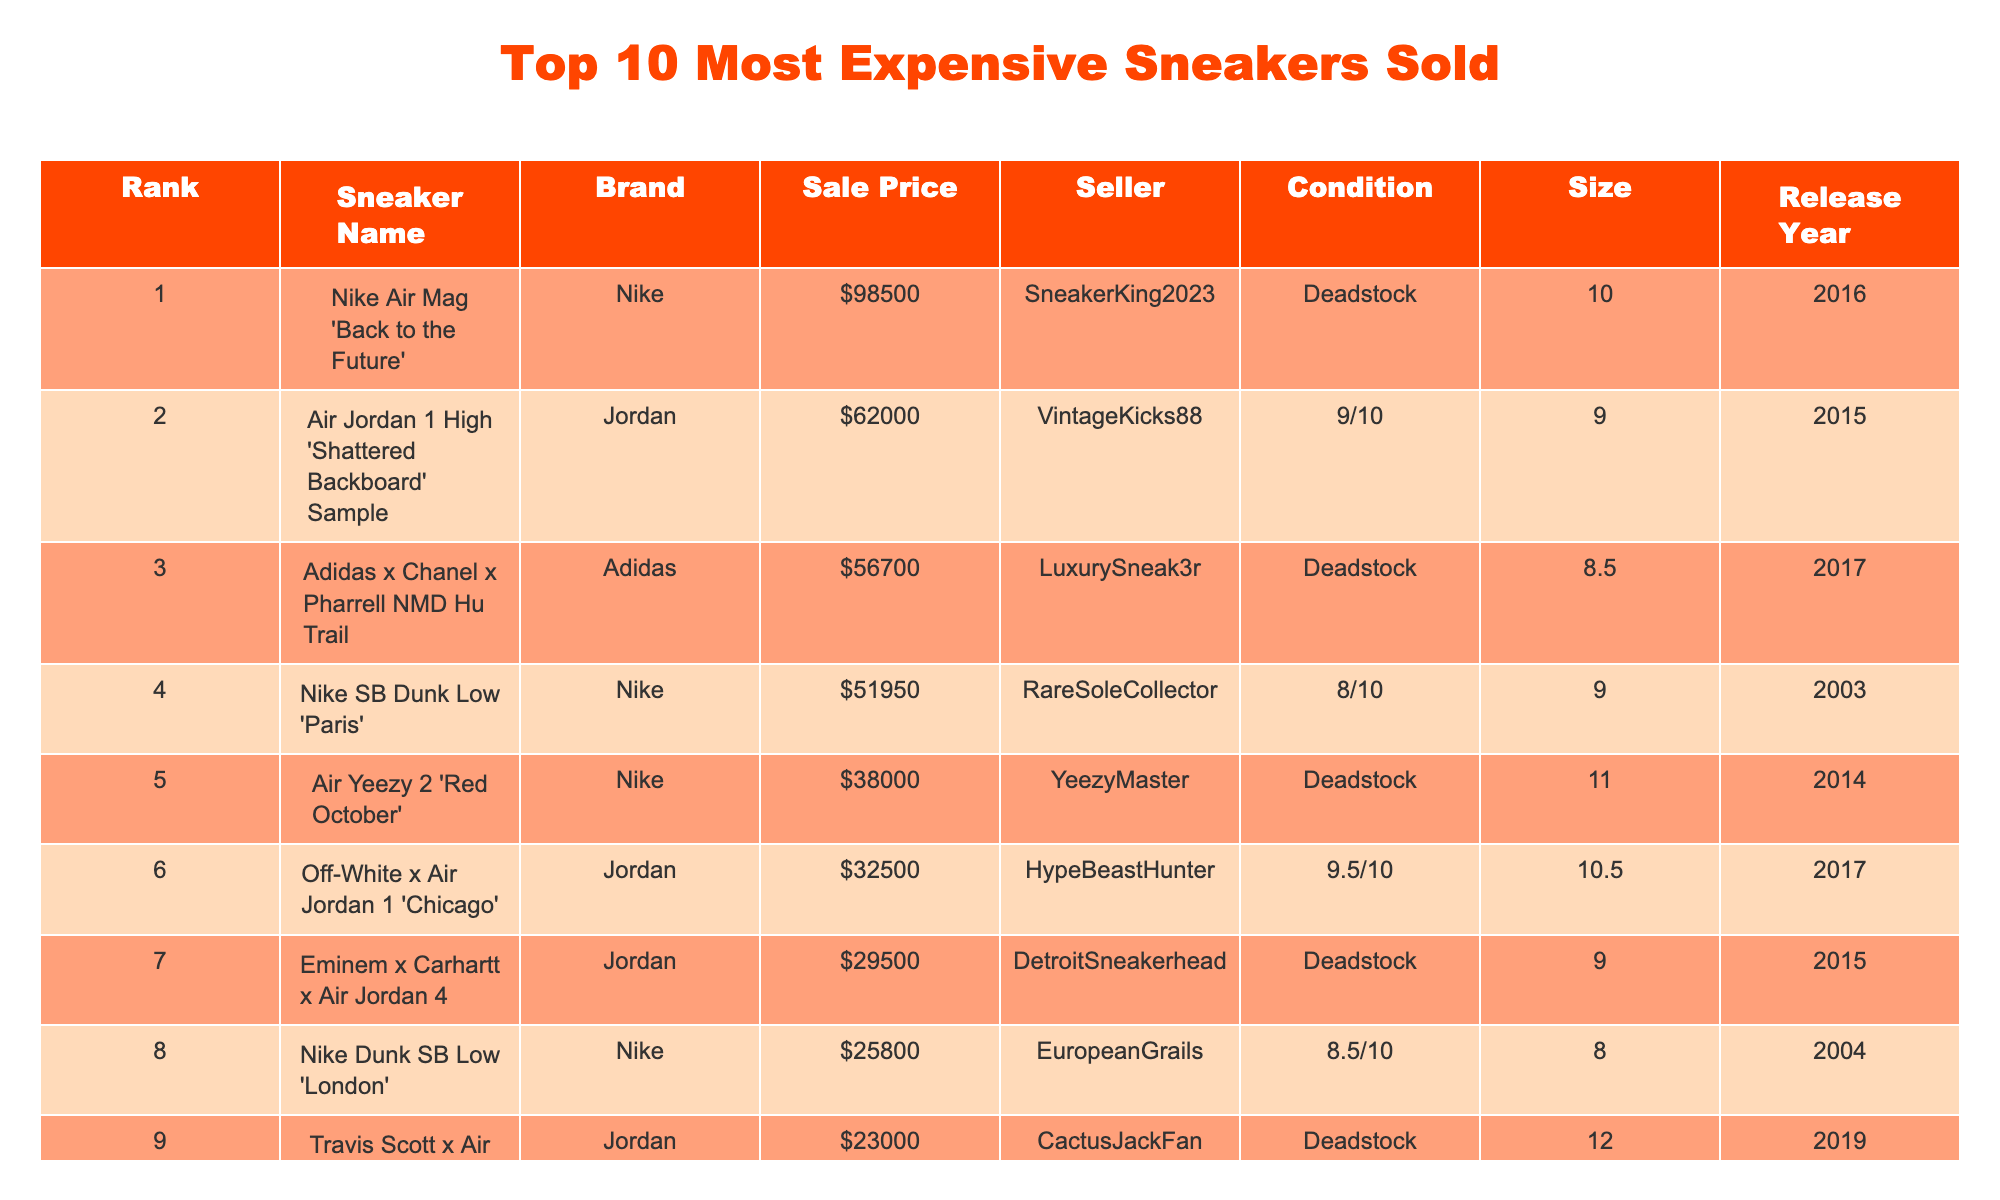What is the sale price of the Nike Air Mag 'Back to the Future'? The table lists the Nike Air Mag 'Back to the Future' with a sale price of $98,500.
Answer: $98,500 Which brand has the most sneakers in the top 10 list? The table shows that Nike has 5 entries (Nike Air Mag, Nike SB Dunk, Air Yeezy, Off-White x Air Jordan, and Nike Dunk) compared to Jordan with 4 entries.
Answer: Nike What is the condition of the sneaker sold for the highest price? The highest-priced sneaker, the Nike Air Mag 'Back to the Future', is listed as deadstock.
Answer: Deadstock How much did the Air Jordan 1 High 'Shattered Backboard' Sample sell for? The table states that the Air Jordan 1 High 'Shattered Backboard' Sample sold for $62,000.
Answer: $62,000 What is the average sale price of all sneakers listed in the table? Adding up all sale prices ($98,500 + $62,000 + $56,700 + $51,950 + $38,000 + $32,500 + $29,500 + $25,800 + $23,000 + $21,500 = $414,450) and dividing by 10 gives an average sale price of $41,445.
Answer: $41,445 Is there a sneaker sold for less than $25,000? The table does not display any sneaker sold for less than $25,000, as the lowest price is $21,500.
Answer: No Which sneaker had the highest sale price among those released in 2017? The Adidas x Chanel x Pharrell NMD Hu Trail, released in 2017, sold for $56,700 and is the highest-priced sneaker from that year.
Answer: Adidas x Chanel x Pharrell NMD Hu Trail How many sneakers listed are deadstock? The table shows that there are six deadstock sneakers (Nike Air Mag, Adidas x Chanel x Pharrell NMD Hu Trail, Air Yeezy 2, Eminem x Carhartt x Air Jordan 4, and Travis Scott x Air Jordan 1).
Answer: 6 What is the difference in sale price between the most expensive and the least expensive sneaker? The most expensive sneaker is the Nike Air Mag at $98,500, and the least expensive is the Kanye West x Louis Vuitton 'Don' at $21,500; the difference is $98,500 - $21,500 = $77,000.
Answer: $77,000 Which sneaker is the oldest in the top 10 list? The Nike SB Dunk Low 'Paris', released in 2003, is the oldest sneaker in the top 10 list.
Answer: Nike SB Dunk Low 'Paris' 